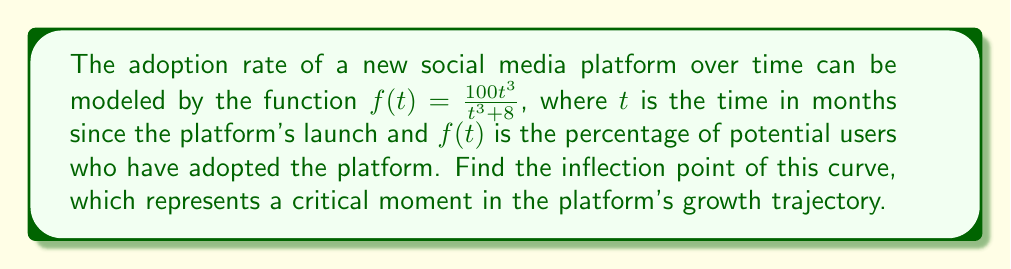Show me your answer to this math problem. To find the inflection point, we need to follow these steps:

1) First, we need to find the first derivative of $f(t)$:
   $$f'(t) = \frac{(t^3 + 8)(300t^2) - 100t^3(3t^2)}{(t^3 + 8)^2}$$
   $$f'(t) = \frac{300t^2(t^3 + 8) - 300t^5}{(t^3 + 8)^2}$$
   $$f'(t) = \frac{300t^2(8)}{(t^3 + 8)^2} = \frac{2400t^2}{(t^3 + 8)^2}$$

2) Now, we find the second derivative:
   $$f''(t) = \frac{(t^3 + 8)^2(4800t) - 2400t^2(2(t^3 + 8)(3t^2))}{(t^3 + 8)^4}$$
   $$f''(t) = \frac{4800t(t^3 + 8)^2 - 14400t^4(t^3 + 8)}{(t^3 + 8)^4}$$
   $$f''(t) = \frac{4800t(t^3 + 8) - 14400t^4}{(t^3 + 8)^3}$$
   $$f''(t) = \frac{4800t^4 + 38400t - 14400t^4}{(t^3 + 8)^3}$$
   $$f''(t) = \frac{38400t - 9600t^4}{(t^3 + 8)^3}$$

3) The inflection point occurs where $f''(t) = 0$:
   $$38400t - 9600t^4 = 0$$
   $$4t - t^4 = 0$$
   $$t(4 - t^3) = 0$$

4) Solving this equation:
   $t = 0$ or $t^3 = 4$
   $t = 0$ or $t = \sqrt[3]{4} = \sqrt[3]{2^2} = 2^{\frac{2}{3}}$

5) Since $t$ represents time, it must be positive. Therefore, the inflection point occurs at:
   $$t = 2^{\frac{2}{3}} \approx 1.5874$$

6) To find the corresponding $f(t)$ value:
   $$f(2^{\frac{2}{3}}) = \frac{100(2^{\frac{2}{3}})^3}{(2^{\frac{2}{3}})^3 + 8} = \frac{100 \cdot 4}{4 + 8} = \frac{400}{12} = \frac{100}{3} \approx 33.33$$

Therefore, the inflection point occurs at approximately 1.5874 months, when about 33.33% of potential users have adopted the platform.
Answer: $(2^{\frac{2}{3}}, \frac{100}{3})$ or approximately $(1.5874, 33.33)$ 